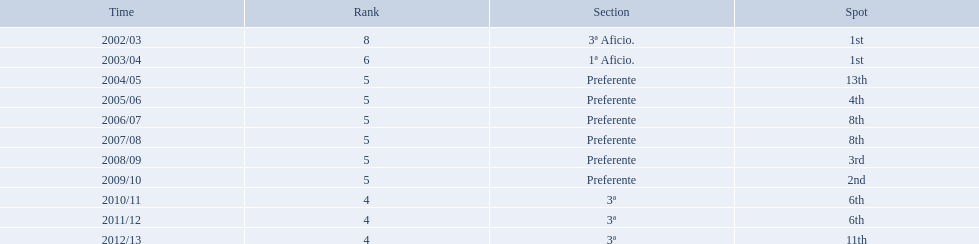Which seasons were played in tier four? 2010/11, 2011/12, 2012/13. Of these seasons, which resulted in 6th place? 2010/11, 2011/12. Which of the remaining happened last? 2011/12. What place did the team place in 2010/11? 6th. In what other year did they place 6th? 2011/12. How many times did  internacional de madrid cf come in 6th place? 6th, 6th. What is the first season that the team came in 6th place? 2010/11. Which season after the first did they place in 6th again? 2011/12. 